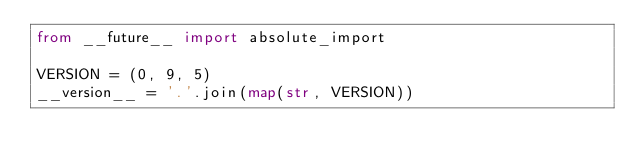<code> <loc_0><loc_0><loc_500><loc_500><_Python_>from __future__ import absolute_import

VERSION = (0, 9, 5)
__version__ = '.'.join(map(str, VERSION))
</code> 